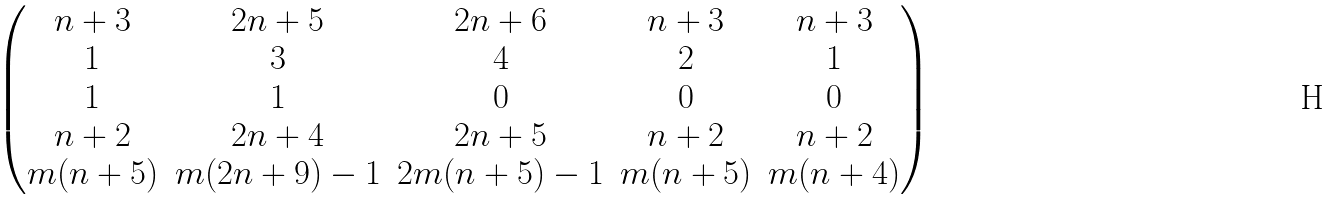<formula> <loc_0><loc_0><loc_500><loc_500>\begin{pmatrix} n + 3 & 2 n + 5 & 2 n + 6 & n + 3 & n + 3 \\ 1 & 3 & 4 & 2 & 1 \\ 1 & 1 & 0 & 0 & 0 \\ n + 2 & 2 n + 4 & 2 n + 5 & n + 2 & n + 2 \\ m ( n + 5 ) & m ( 2 n + 9 ) - 1 & 2 m ( n + 5 ) - 1 & m ( n + 5 ) & m ( n + 4 ) \end{pmatrix}</formula> 